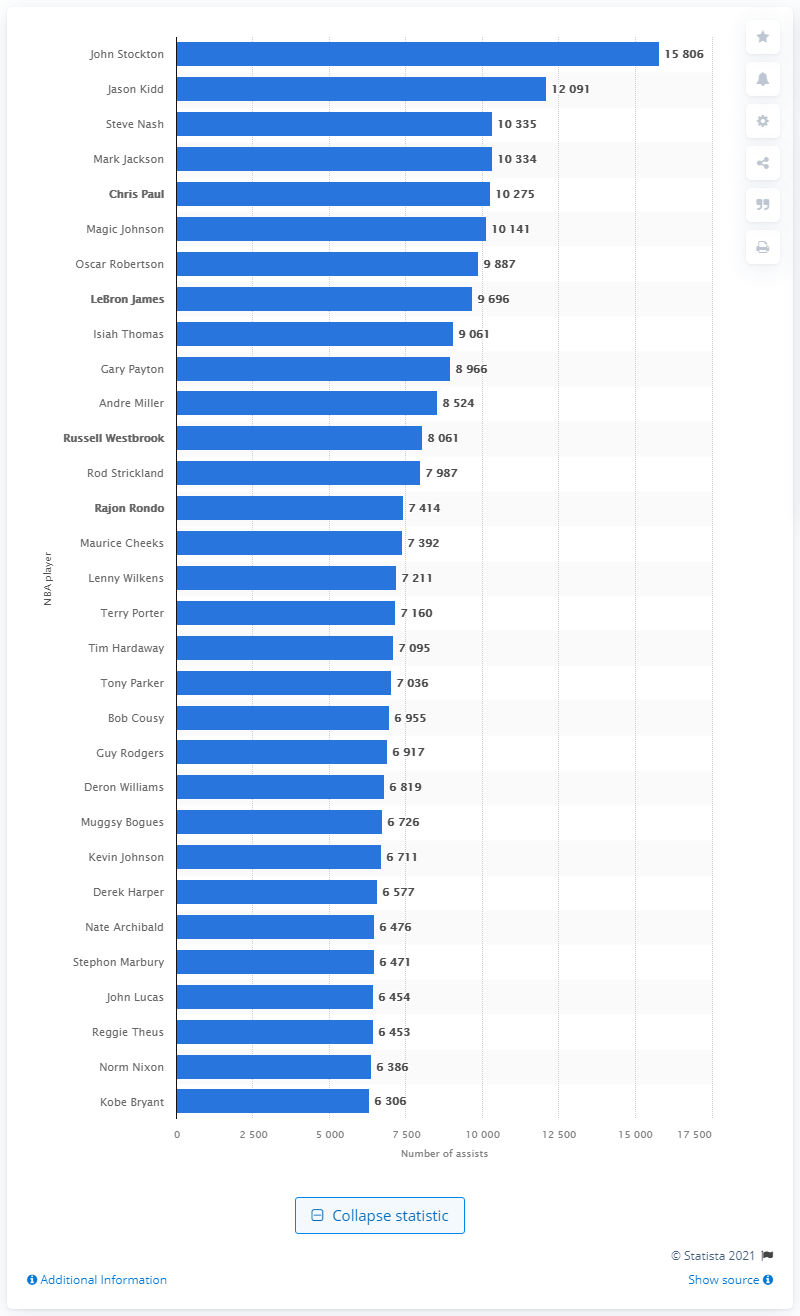Draw attention to some important aspects in this diagram. John Stockton is the all-time assists leader of the National Basketball Association. As of my knowledge cutoff date of September 2021, the highest ranked player still active in the National Basketball Association (NBA) is Chris Paul, who is widely regarded as one of the greatest point guards of all time. 